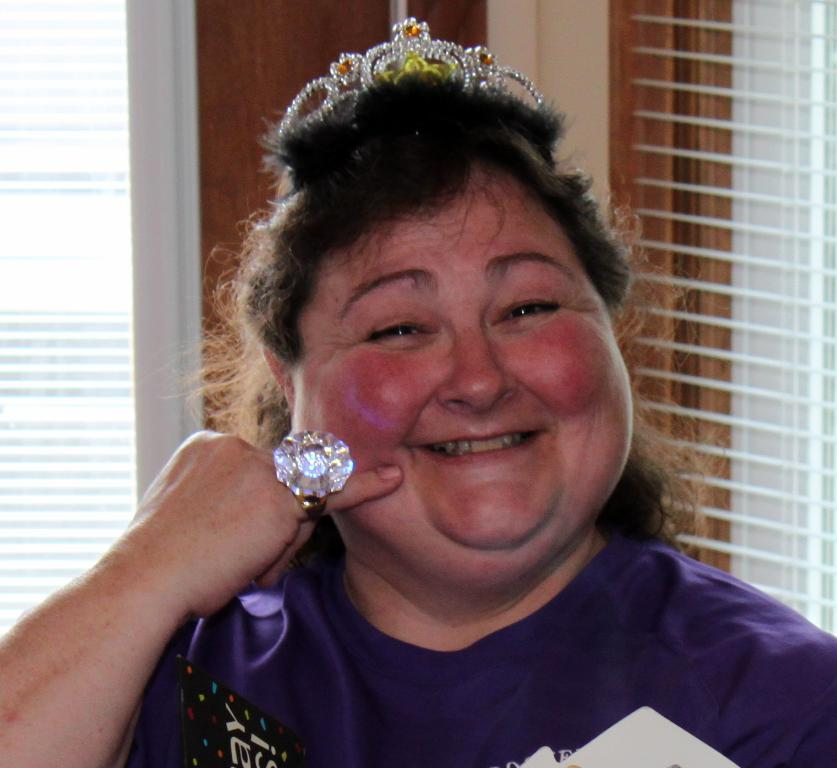Who is the main subject in the image? There is a woman in the image. What is the woman wearing on her head? The woman is wearing a crown. What type of jewelry is the woman wearing? The woman is wearing a finger ring. What is the woman's facial expression? The woman is smiling. What can be seen in the background of the image? There is a wooden object, window shades, and glass objects in the background of the image. What type of behavior do the cats exhibit in the image? There are no cats present in the image, so their behavior cannot be observed. What kind of arch can be seen in the background of the image? There is no arch present in the image; only a wooden object, window shades, and glass objects can be seen in the background. 